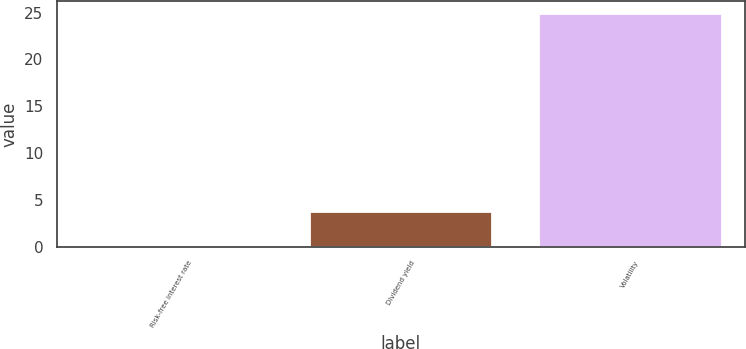Convert chart to OTSL. <chart><loc_0><loc_0><loc_500><loc_500><bar_chart><fcel>Risk-free interest rate<fcel>Dividend yield<fcel>Volatility<nl><fcel>0.2<fcel>3.8<fcel>25<nl></chart> 